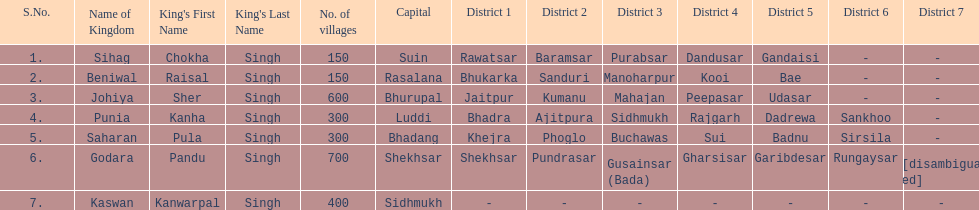What was the total number of districts within the state of godara? 7. 